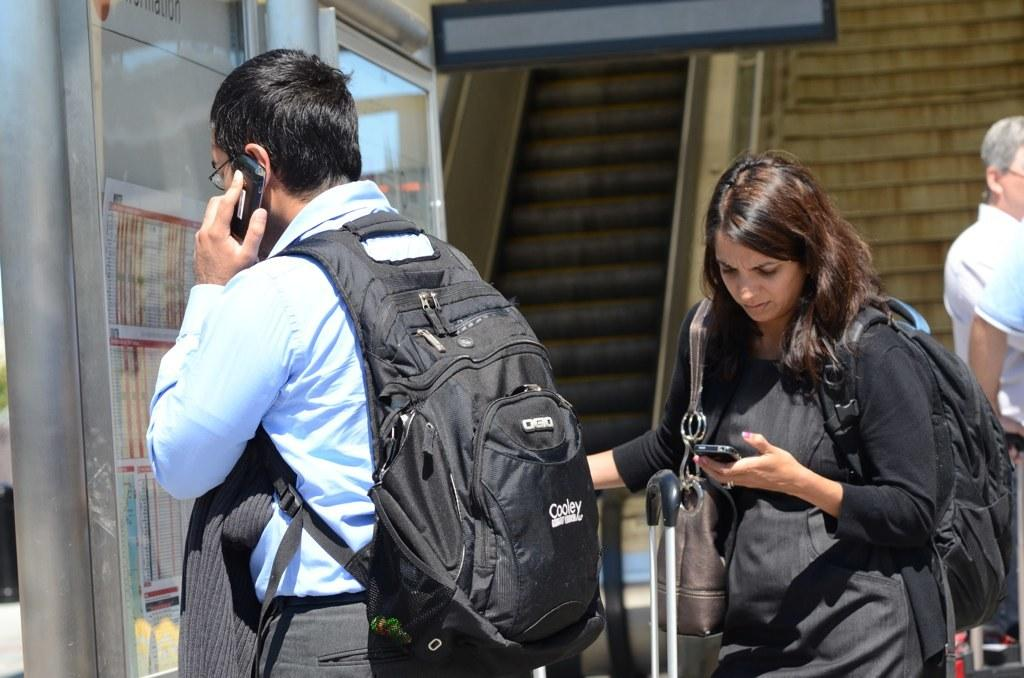<image>
Present a compact description of the photo's key features. A man is wearing a Cooley brand backpack and talking on the phone. 